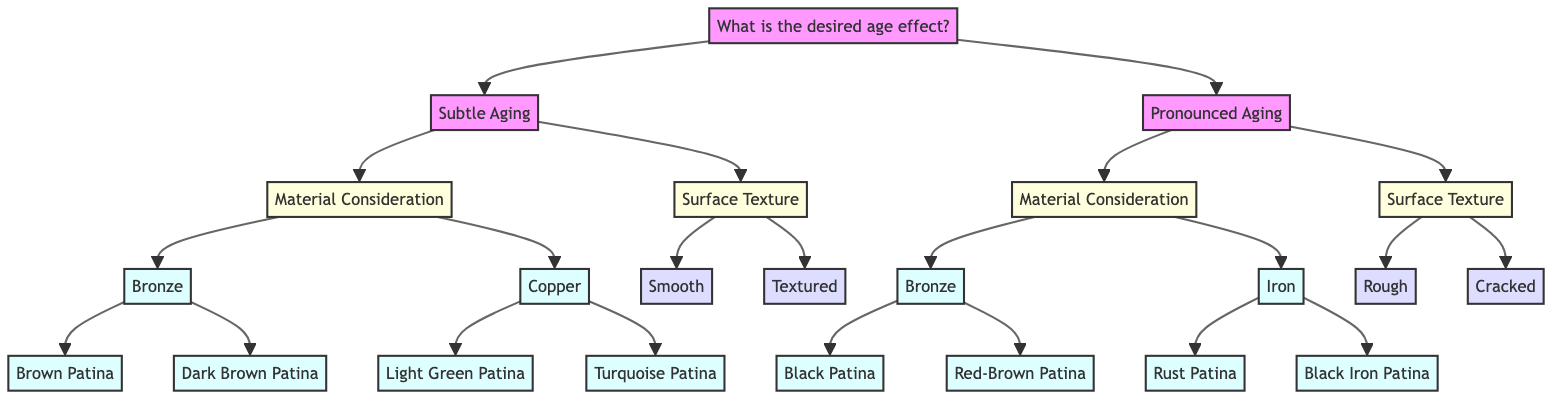What are the two main options for the desired age effect? The diagram starts with the node "What is the desired age effect?" which branches out into two main options: "Subtle Aging" and "Pronounced Aging".
Answer: Subtle Aging, Pronounced Aging Which material option links to the patina type "Black Patina"? Tracing from "Pronounced Aging" to "Material Consideration" leads to "Bronze", which further branches to the "Patina Type" option "Black Patina".
Answer: Bronze How many surface texture options are provided under "Subtle Aging"? Under the "Subtle Aging" node, there are two branches for "Surface Texture": "Smooth" and "Textured", which means there are a total of two options for surface texture.
Answer: 2 Which patina type for Copper replicates natural aging? From "Copper" under "Material Consideration", the only patina type that focuses on natural aging is "Light Green Patina", which aims to create a fresh verdigris effect.
Answer: Light Green Patina What is the relationship between "Rough" and "Pronounced Aging"? "Rough" is a surface texture option that is directly connected under "Surface Texture", which you can navigate to after choosing "Pronounced Aging".
Answer: Surface Texture under Pronounced Aging Which patina type would you choose for a deeply aged look in Iron? The patina type listed under Iron that creates a deeply aged, antique appearance is "Black Iron Patina", located under the "Patina Type" options for Iron.
Answer: Black Iron Patina How does "Textured" affect the appearance of a sculpture? The "Textured" option is outlined under "Surface Texture" in "Subtle Aging" as an enhancer for depth and detail in the aged appearance of the sculpture.
Answer: Accentuates depth and detail Which patina type would create a warm, aged finish with slight green highlights? This description corresponds to the "Brown Patina" for Bronze, shown in the "Patina Type" options linked under "Material Consideration" for "Bronze".
Answer: Brown Patina 